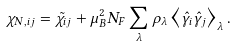Convert formula to latex. <formula><loc_0><loc_0><loc_500><loc_500>\chi _ { N , i j } = \tilde { \chi } _ { i j } + \mu _ { B } ^ { 2 } N _ { F } \sum _ { \lambda } \rho _ { \lambda } \left \langle \hat { \gamma } _ { i } \hat { \gamma } _ { j } \right \rangle _ { \lambda } .</formula> 